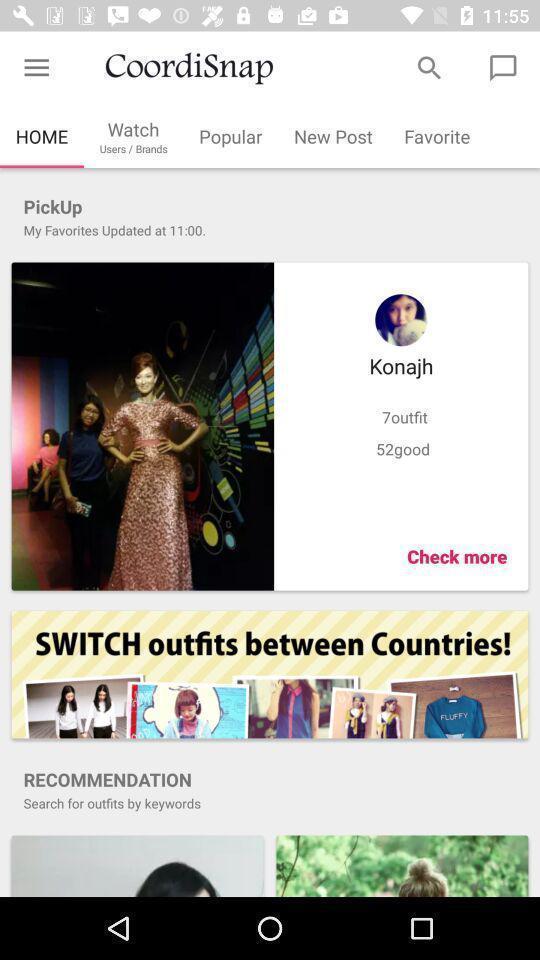Provide a description of this screenshot. Screen showing home page with options. 